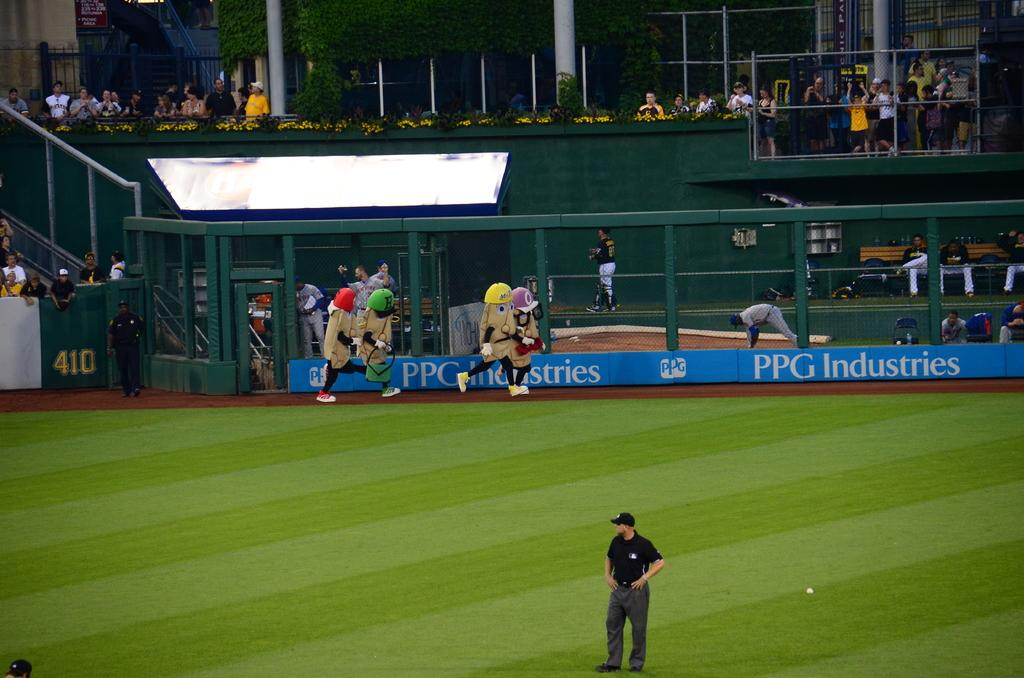Provide a one-sentence caption for the provided image. A baseball field with four mascots that look like potatoes in hats running next to the PPG Industries banner. 